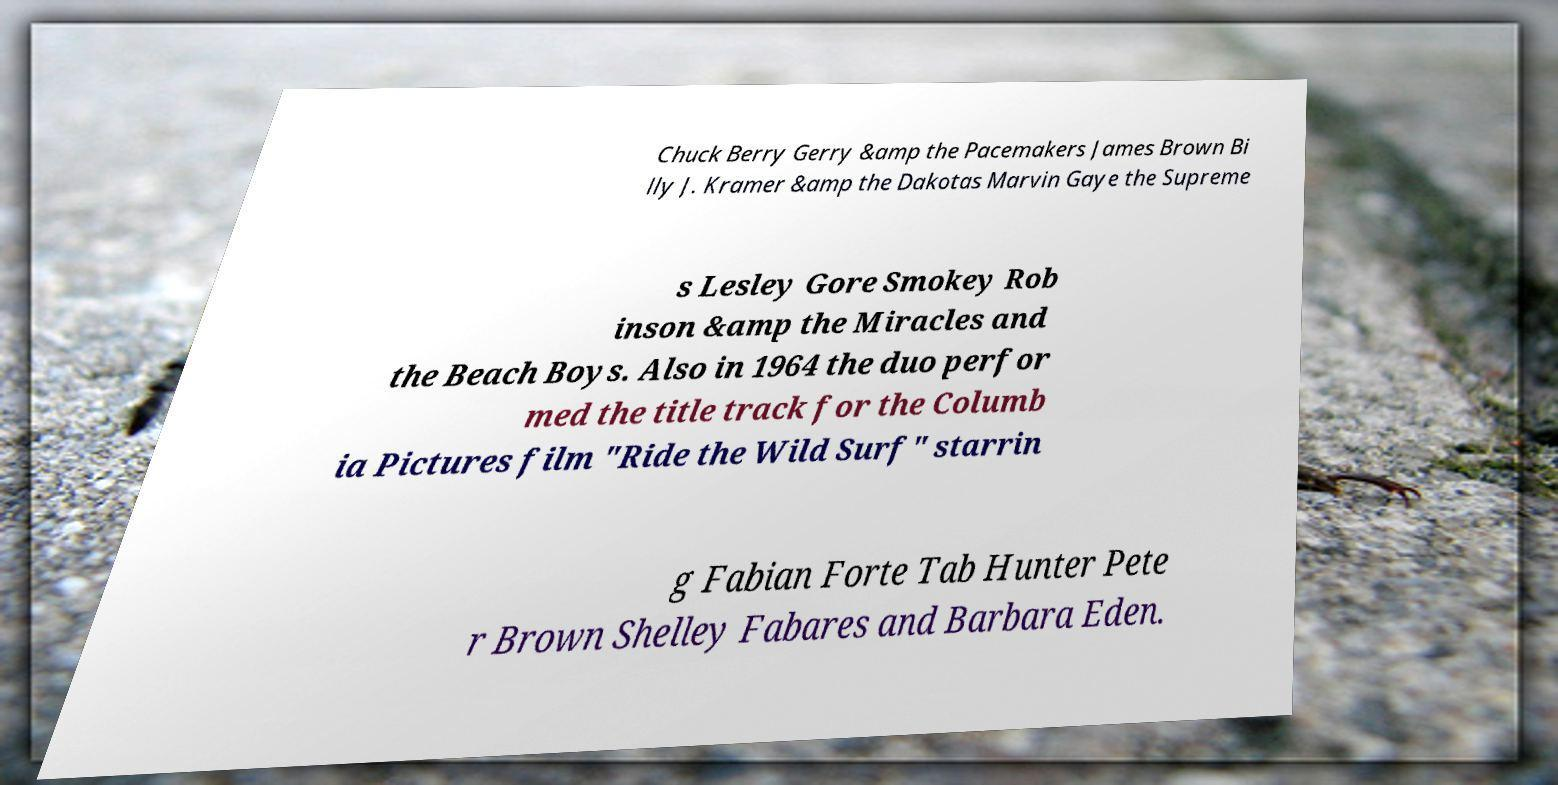Could you assist in decoding the text presented in this image and type it out clearly? Chuck Berry Gerry &amp the Pacemakers James Brown Bi lly J. Kramer &amp the Dakotas Marvin Gaye the Supreme s Lesley Gore Smokey Rob inson &amp the Miracles and the Beach Boys. Also in 1964 the duo perfor med the title track for the Columb ia Pictures film "Ride the Wild Surf" starrin g Fabian Forte Tab Hunter Pete r Brown Shelley Fabares and Barbara Eden. 